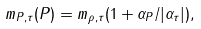Convert formula to latex. <formula><loc_0><loc_0><loc_500><loc_500>m _ { P , \tau } ( P ) = m _ { \rho , \tau } ( 1 + \alpha _ { P } / | \alpha _ { \tau } | ) ,</formula> 